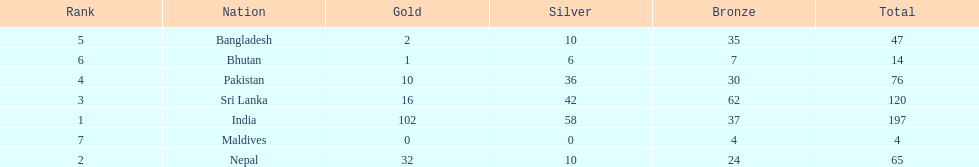Which countries won medals? India, Nepal, Sri Lanka, Pakistan, Bangladesh, Bhutan, Maldives. Which won the most? India. Which won the fewest? Maldives. 